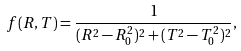Convert formula to latex. <formula><loc_0><loc_0><loc_500><loc_500>f ( R , T ) = \frac { 1 } { ( R ^ { 2 } - R _ { 0 } ^ { 2 } ) ^ { 2 } + ( T ^ { 2 } - T _ { 0 } ^ { 2 } ) ^ { 2 } } ,</formula> 